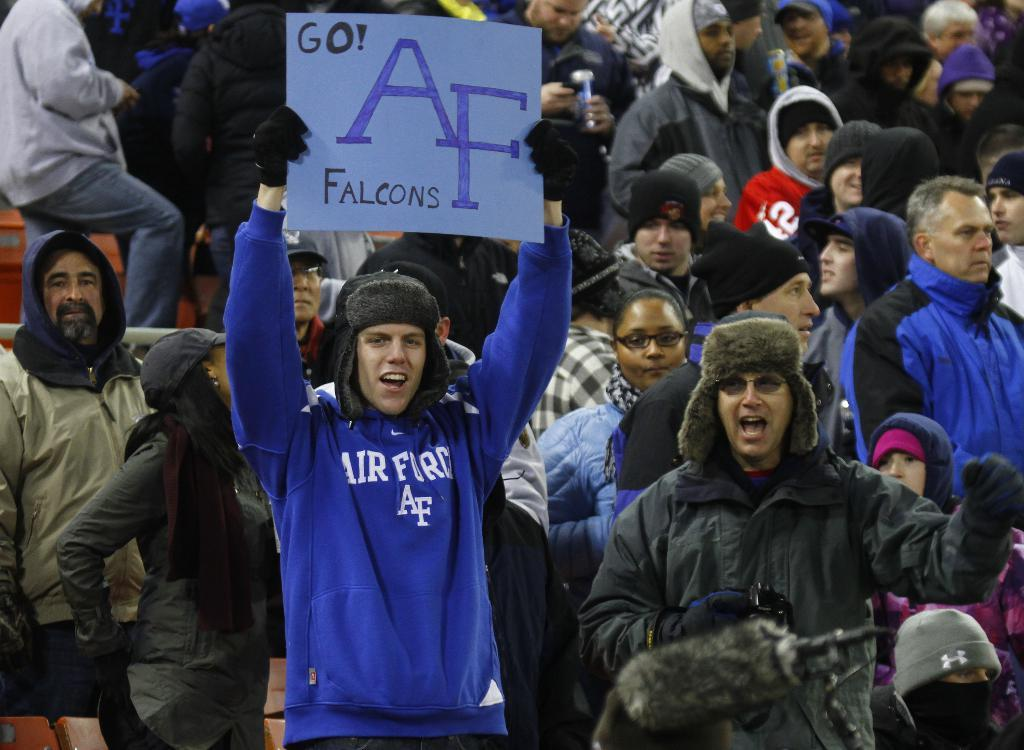How many people are in the image? There is a group of people in the image. What is one person in the group doing? One person is holding a board. What type of truck is parked next to the group of people in the image? There is no truck present in the image. What knowledge is being shared among the group of people in the image? The image does not provide information about the knowledge being shared among the group of people. 